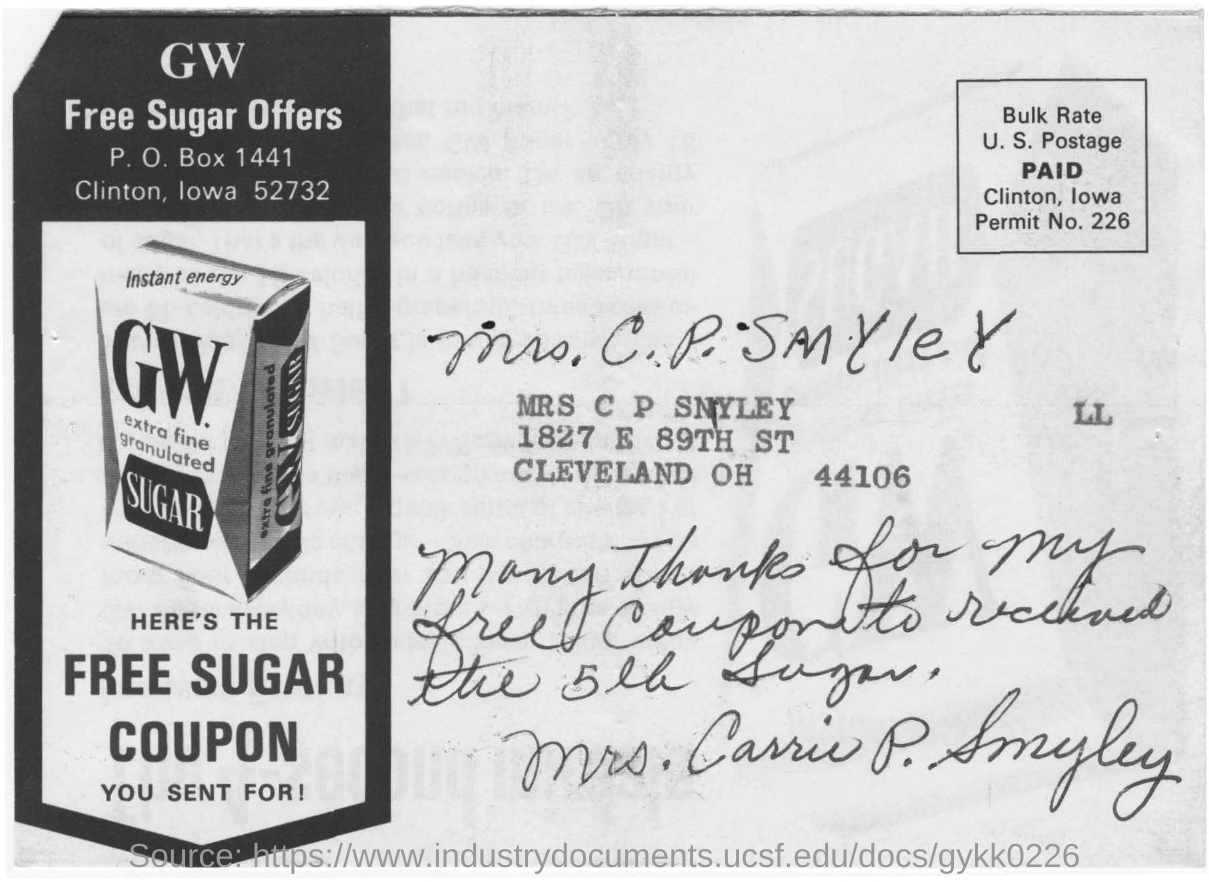Specify some key components in this picture. The name of the company is GW. The picture shows a company offering a FREE SUGAR COUPON. The name mentioned in this document is MRS C P SMYLEY. 